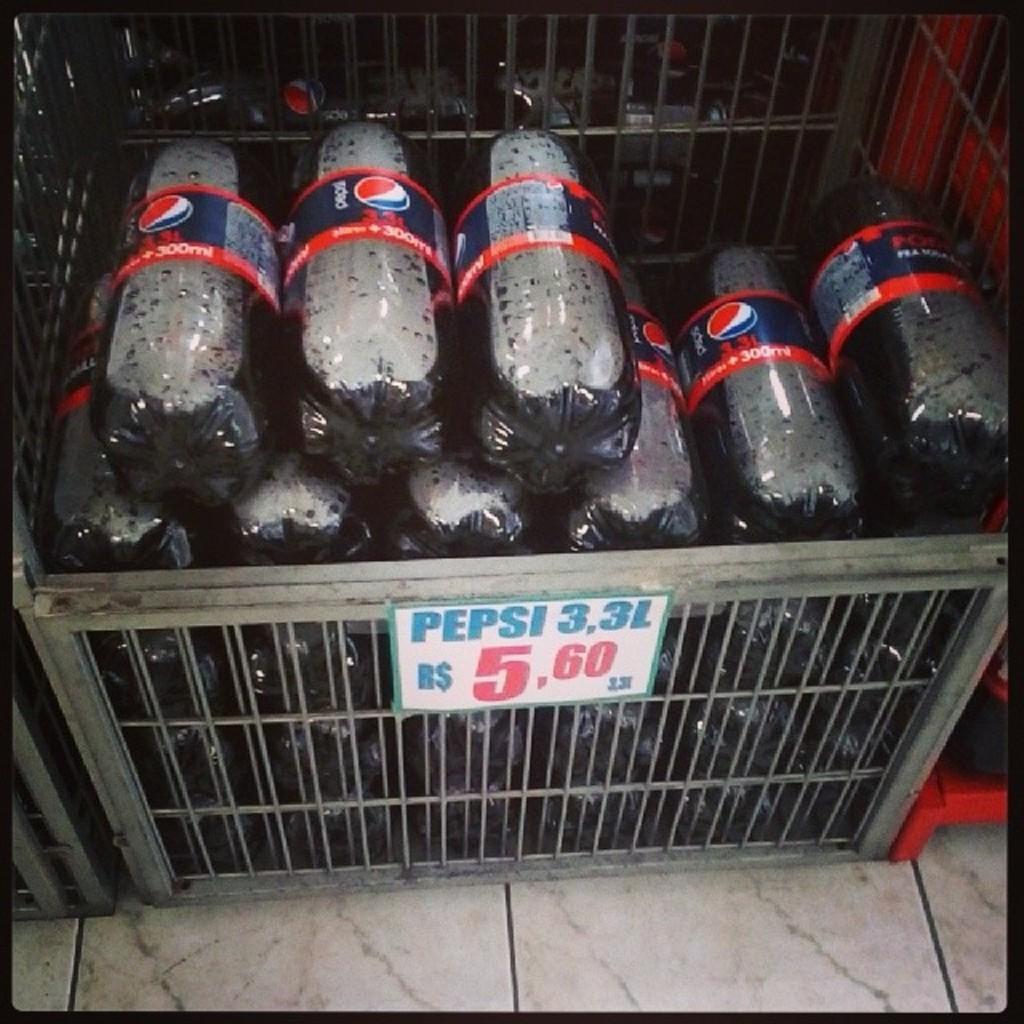How would you summarize this image in a sentence or two? In this image I can see a box in which bottles are filled. 